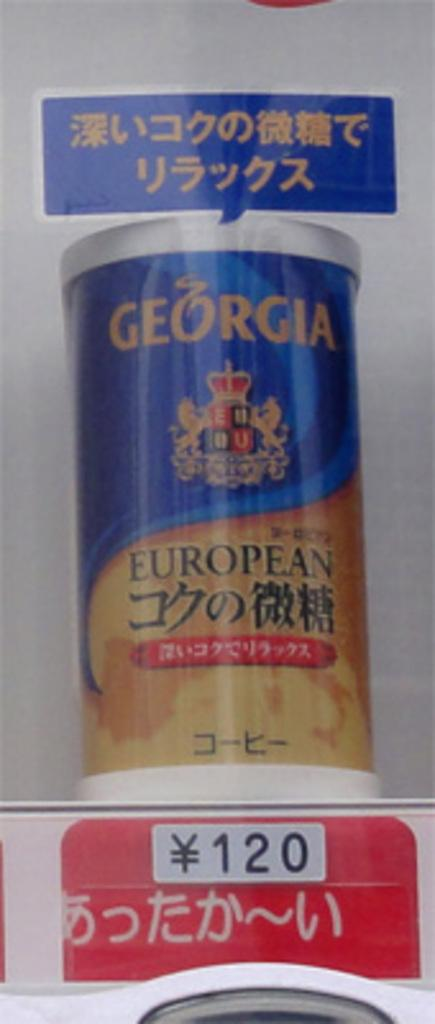<image>
Render a clear and concise summary of the photo. A Georgia product that can be purchased for a cost of 120 of the local currency. 